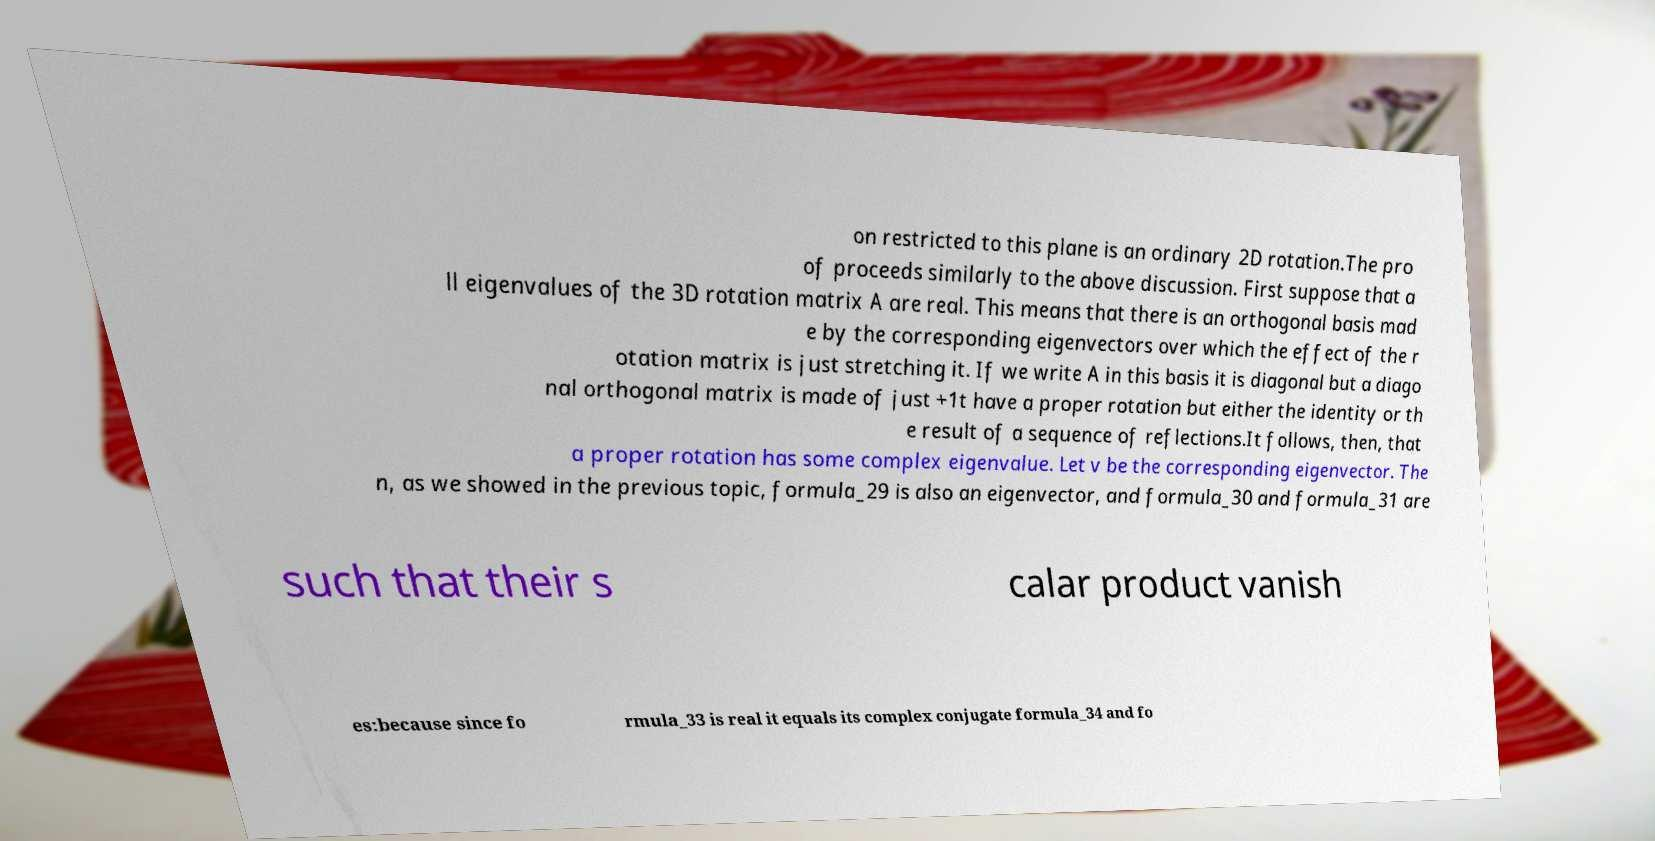For documentation purposes, I need the text within this image transcribed. Could you provide that? on restricted to this plane is an ordinary 2D rotation.The pro of proceeds similarly to the above discussion. First suppose that a ll eigenvalues of the 3D rotation matrix A are real. This means that there is an orthogonal basis mad e by the corresponding eigenvectors over which the effect of the r otation matrix is just stretching it. If we write A in this basis it is diagonal but a diago nal orthogonal matrix is made of just +1t have a proper rotation but either the identity or th e result of a sequence of reflections.It follows, then, that a proper rotation has some complex eigenvalue. Let v be the corresponding eigenvector. The n, as we showed in the previous topic, formula_29 is also an eigenvector, and formula_30 and formula_31 are such that their s calar product vanish es:because since fo rmula_33 is real it equals its complex conjugate formula_34 and fo 